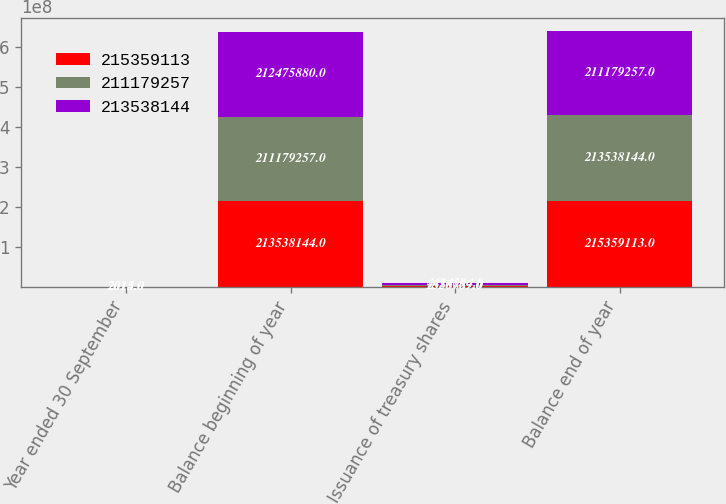Convert chart. <chart><loc_0><loc_0><loc_500><loc_500><stacked_bar_chart><ecel><fcel>Year ended 30 September<fcel>Balance beginning of year<fcel>Issuance of treasury shares<fcel>Balance end of year<nl><fcel>2.15359e+08<fcel>2015<fcel>2.13538e+08<fcel>1.82097e+06<fcel>2.15359e+08<nl><fcel>2.11179e+08<fcel>2014<fcel>2.11179e+08<fcel>2.35889e+06<fcel>2.13538e+08<nl><fcel>2.13538e+08<fcel>2013<fcel>2.12476e+08<fcel>4.42439e+06<fcel>2.11179e+08<nl></chart> 